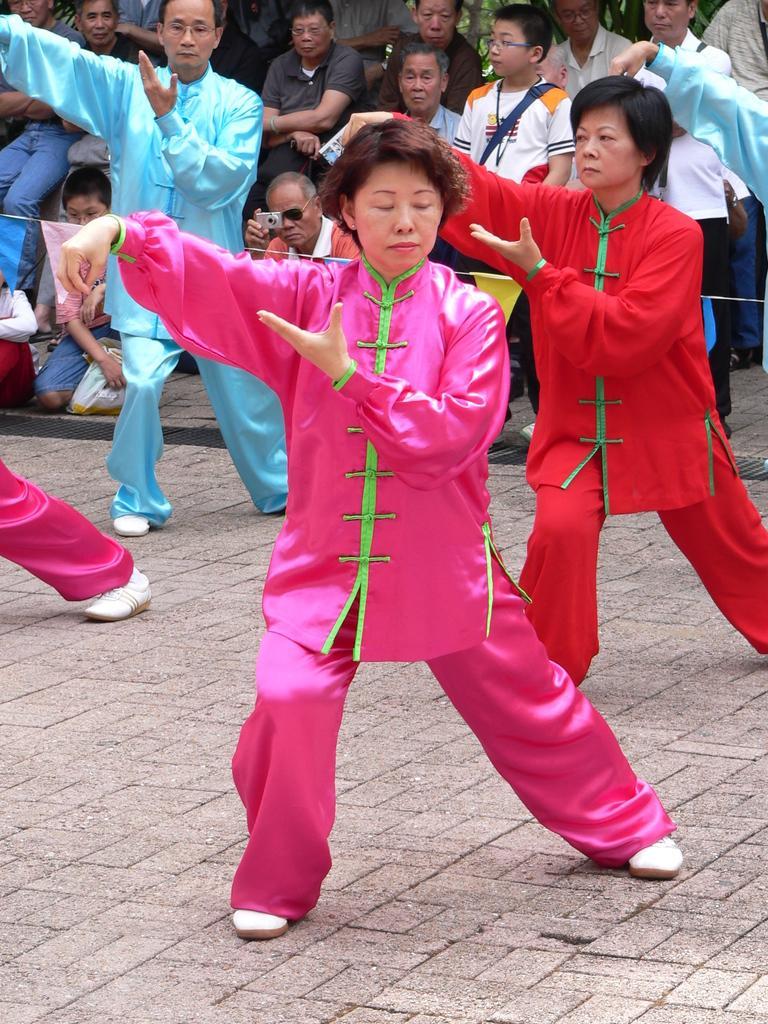Could you give a brief overview of what you see in this image? In the background we can see people. This picture is mainly highlighted with people wearing colorful dresses and it seems like they are dancing on the floor. 